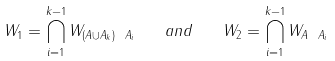<formula> <loc_0><loc_0><loc_500><loc_500>W _ { 1 } = \bigcap _ { i = 1 } ^ { k - 1 } W _ { ( A \cup A _ { k } ) \ A _ { i } } \quad a n d \quad W _ { 2 } = \bigcap _ { i = 1 } ^ { k - 1 } W _ { A \ A _ { i } }</formula> 